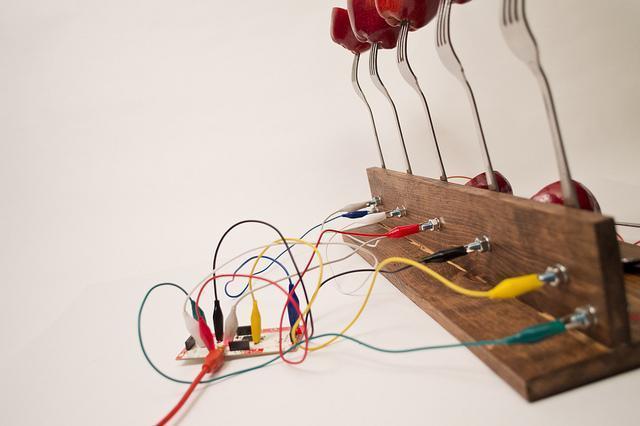How many plugs are on the board?
Give a very brief answer. 6. 